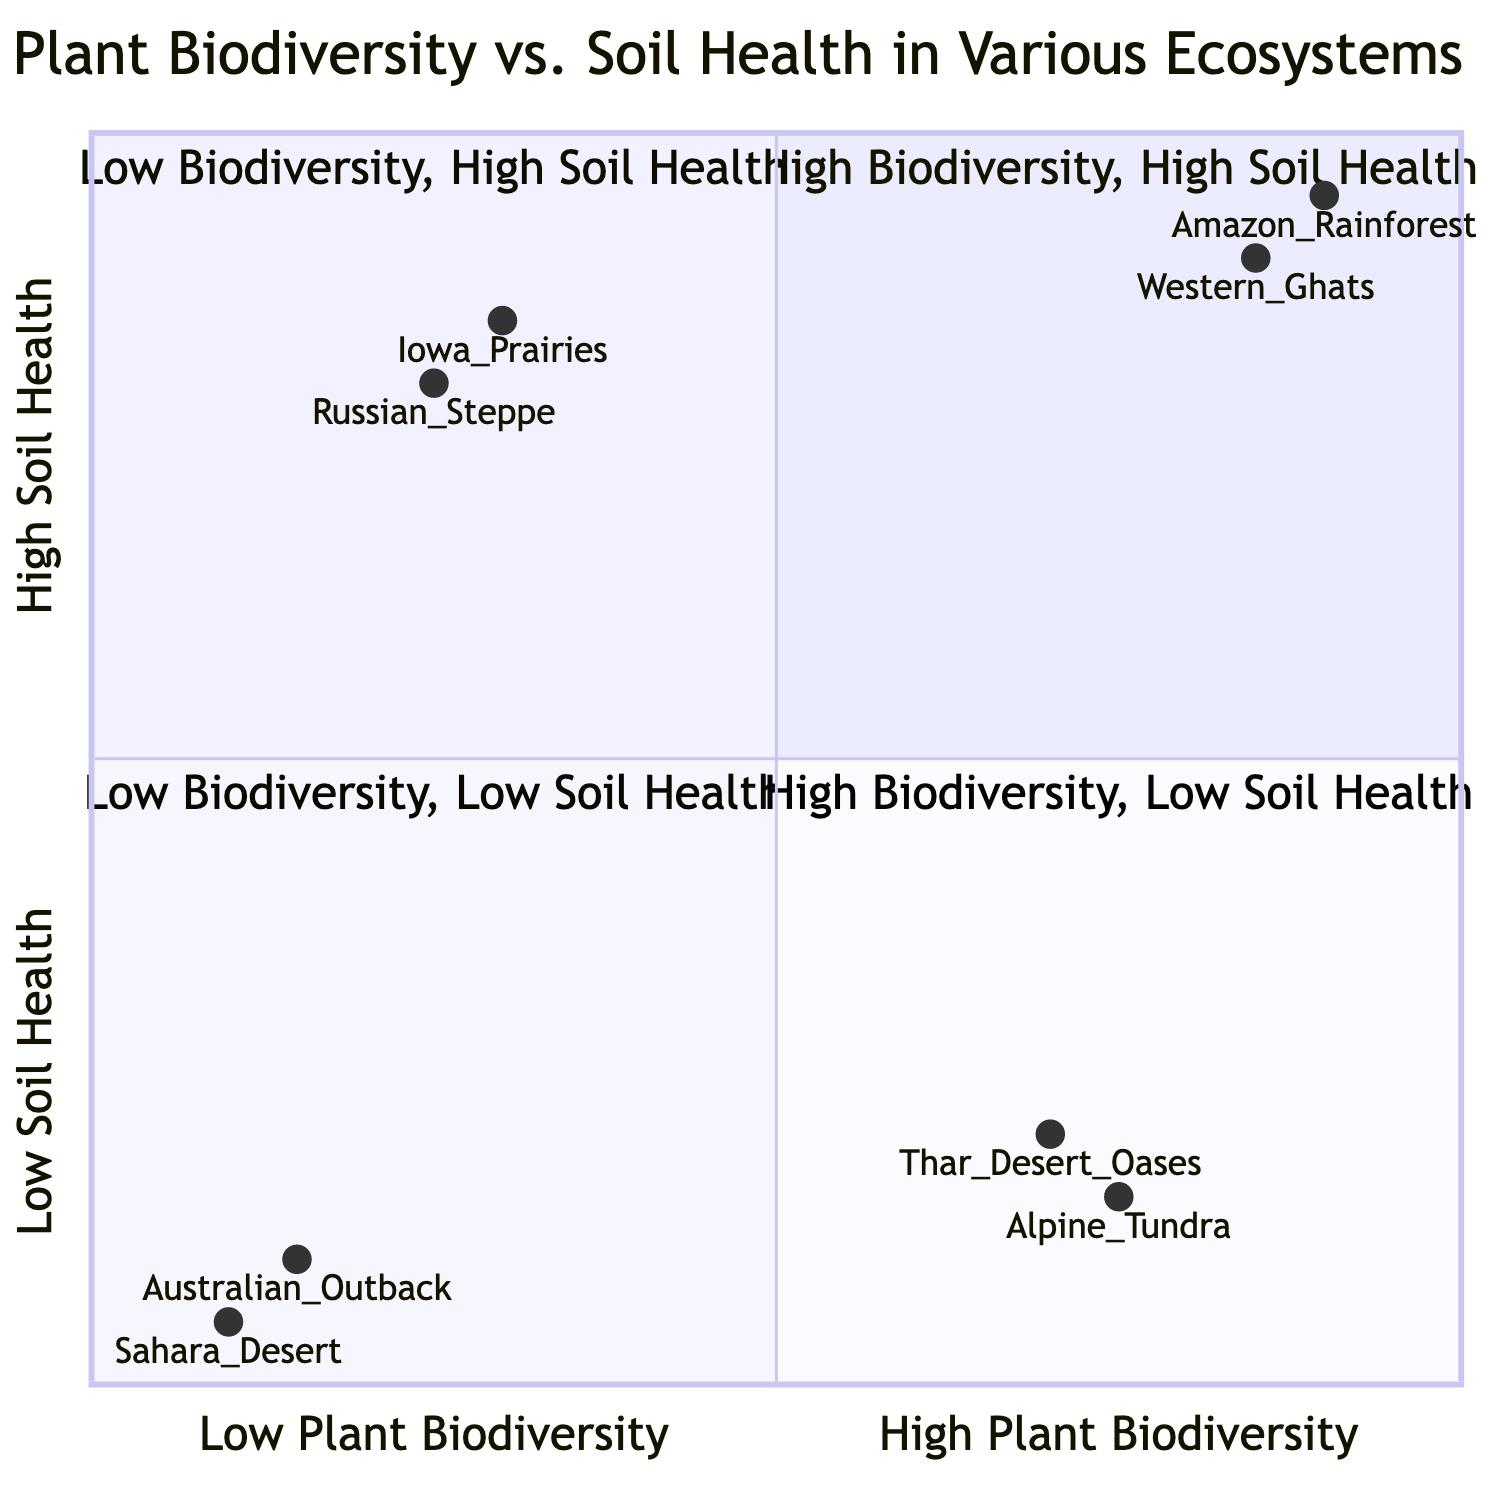What ecosystem has the highest plant biodiversity and soil health? By examining the quadrant that represents high plant biodiversity and high soil health, we can notice the Amazon Rainforest is listed as an example with its respective characteristics, making it the finest candidate.
Answer: Amazon Rainforest How many examples of ecosystems are provided in the "High Plant Biodiversity, Low Soil Health" quadrant? In the "High Plant Biodiversity, Low Soil Health" quadrant, there are two distinct ecosystems provided as examples (Thar Desert Oases and Alpine Tundra), which can be counted directly from the list.
Answer: 2 What is the soil property described for the Iowa Prairies? The soil property for Iowa Prairies is mentioned directly in the diagram as "Thick topsoil, high organic content, excellent structure and fertility," which can be retrieved verbatim from the quadrant description.
Answer: Thick topsoil, high organic content, excellent structure and fertility Which ecosystem is associated with the lowest level of soil health? The Sahara Desert is described in the "Low Plant Biodiversity, Low Soil Health" quadrant, where it is noted that it has extremely sandy soils and low organic matter, indicating it has the lowest soil health among the listed ecosystems.
Answer: Sahara Desert Which quadrant contains the Russian Steppe? By referencing the placement of the Russian Steppe in the diagram, it can be identified under the "Low Plant Biodiversity, High Soil Health" quadrant, as it is consistently categorized in this section.
Answer: Low Plant Biodiversity, High Soil Health What is the x-axis label of the chart? The x-axis label of the chart is specified as "Low Plant Biodiversity --> High Plant Biodiversity," clearly indicating the direction and measurement reference for plant biodiversity within the diagram.
Answer: Low Plant Biodiversity --> High Plant Biodiversity How does the soil health of the Sahara Desert compare to that of the Australian Outback? Both ecosystems are in the "Low Plant Biodiversity, Low Soil Health" quadrant, but comparing their specific properties, the Sahara Desert has "extremely sandy soils, low organic matter," while the Australian Outback has "poorly structured, low nutrient availability," indicating a similar low health but differing characteristics.
Answer: Similar low health What are the characteristics of the soil in the Amazon Rainforest? The soil properties attributed to the Amazon Rainforest include "High organic matter, rich in nutrients, strong microbial activity," which are distinctively listed in the quadrant examples, directly answering the inquiry about soil characteristics in this ecosystem.
Answer: High organic matter, rich in nutrients, strong microbial activity 